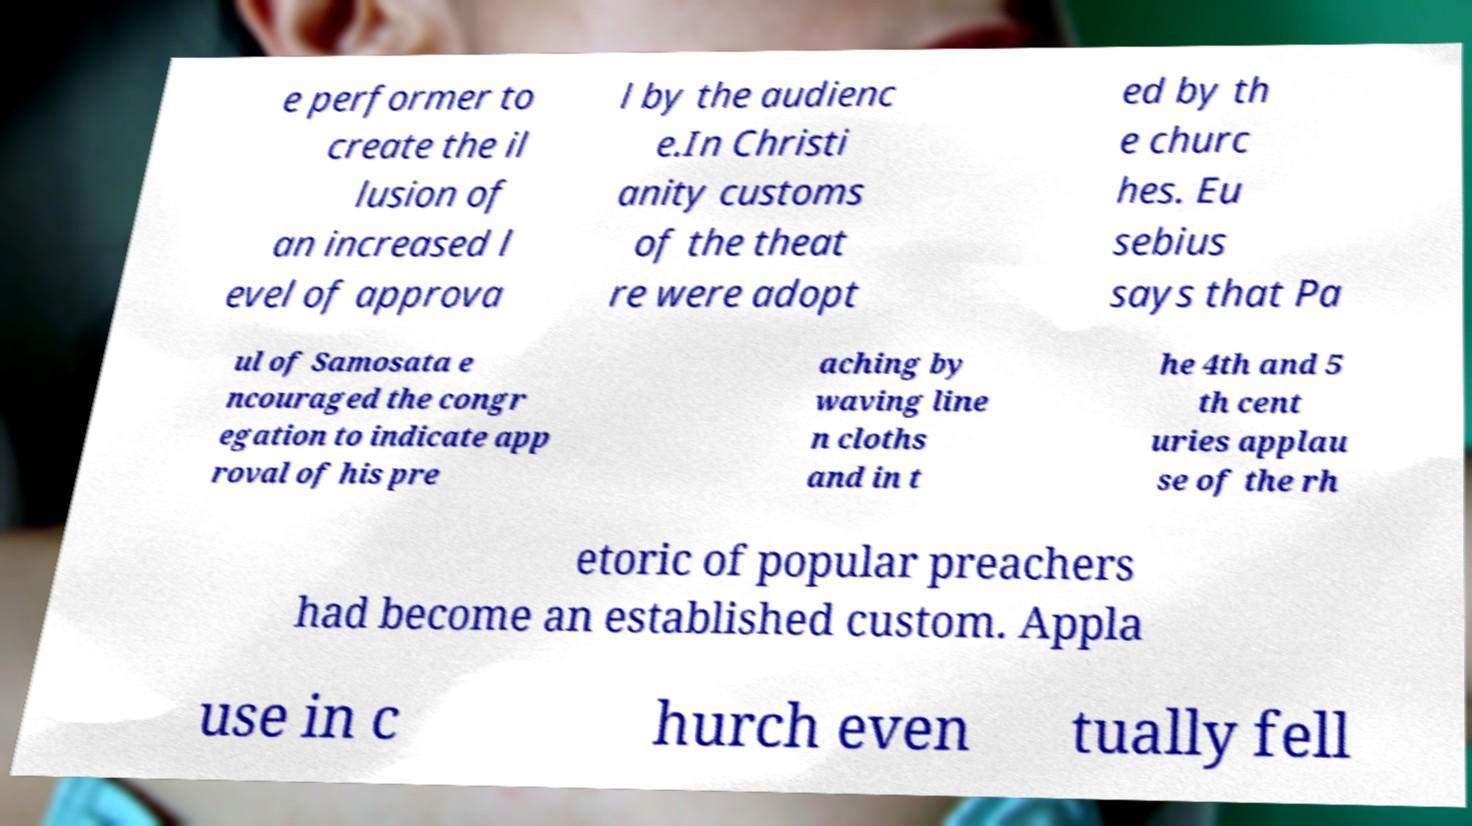Please read and relay the text visible in this image. What does it say? e performer to create the il lusion of an increased l evel of approva l by the audienc e.In Christi anity customs of the theat re were adopt ed by th e churc hes. Eu sebius says that Pa ul of Samosata e ncouraged the congr egation to indicate app roval of his pre aching by waving line n cloths and in t he 4th and 5 th cent uries applau se of the rh etoric of popular preachers had become an established custom. Appla use in c hurch even tually fell 